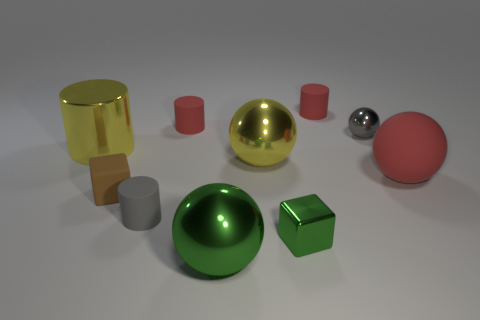Are there the same number of big yellow metal objects that are in front of the yellow sphere and yellow shiny spheres?
Offer a terse response. No. How many big yellow metallic cylinders are behind the big yellow metal object to the right of the big metallic sphere in front of the small brown rubber thing?
Your answer should be very brief. 1. There is a small rubber cylinder to the right of the small green metallic cube; what is its color?
Your answer should be very brief. Red. What is the material of the small object that is both left of the yellow sphere and behind the tiny brown block?
Offer a terse response. Rubber. What number of tiny cubes are to the right of the small shiny object left of the tiny gray metal ball?
Provide a short and direct response. 0. The gray shiny object is what shape?
Keep it short and to the point. Sphere. What shape is the large green thing that is the same material as the small gray ball?
Keep it short and to the point. Sphere. Does the big green metallic object in front of the small gray sphere have the same shape as the gray shiny object?
Provide a short and direct response. Yes. There is a large yellow thing that is to the left of the yellow metal ball; what is its shape?
Your answer should be very brief. Cylinder. The big thing that is the same color as the large cylinder is what shape?
Your answer should be very brief. Sphere. 